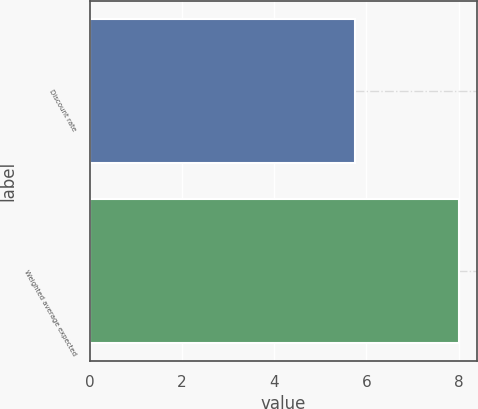<chart> <loc_0><loc_0><loc_500><loc_500><bar_chart><fcel>Discount rate<fcel>Weighted average expected<nl><fcel>5.75<fcel>8<nl></chart> 